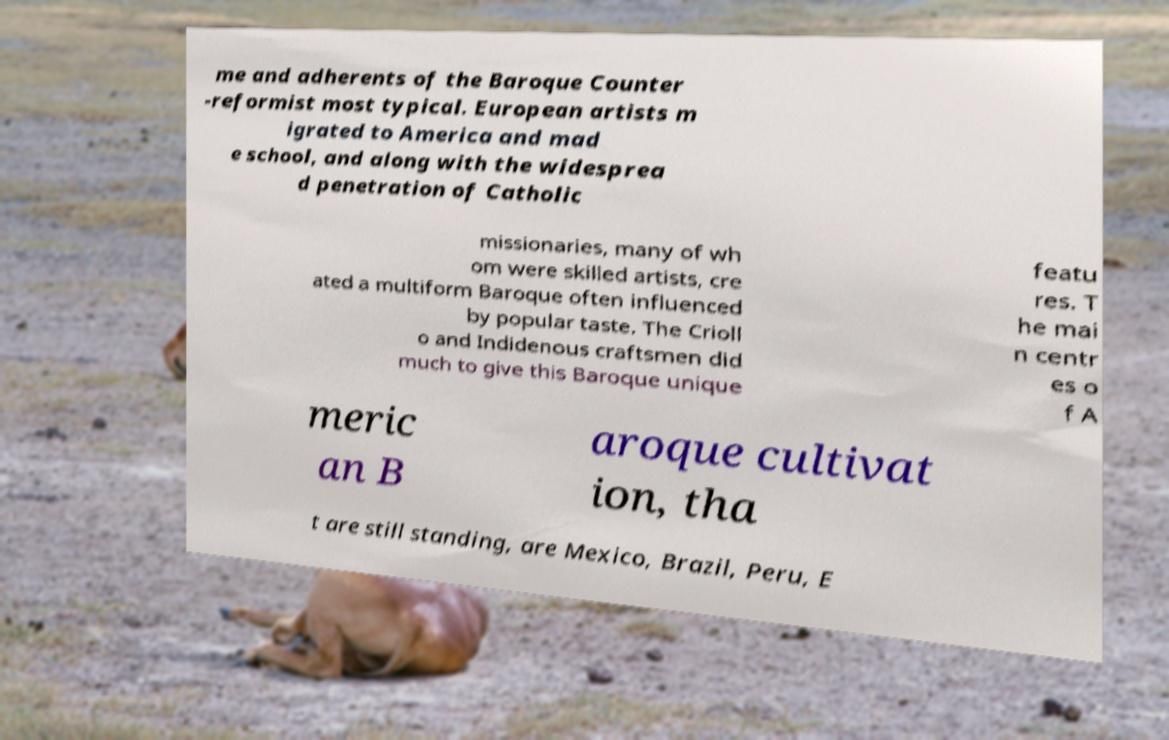Can you accurately transcribe the text from the provided image for me? me and adherents of the Baroque Counter -reformist most typical. European artists m igrated to America and mad e school, and along with the widesprea d penetration of Catholic missionaries, many of wh om were skilled artists, cre ated a multiform Baroque often influenced by popular taste. The Crioll o and Indidenous craftsmen did much to give this Baroque unique featu res. T he mai n centr es o f A meric an B aroque cultivat ion, tha t are still standing, are Mexico, Brazil, Peru, E 